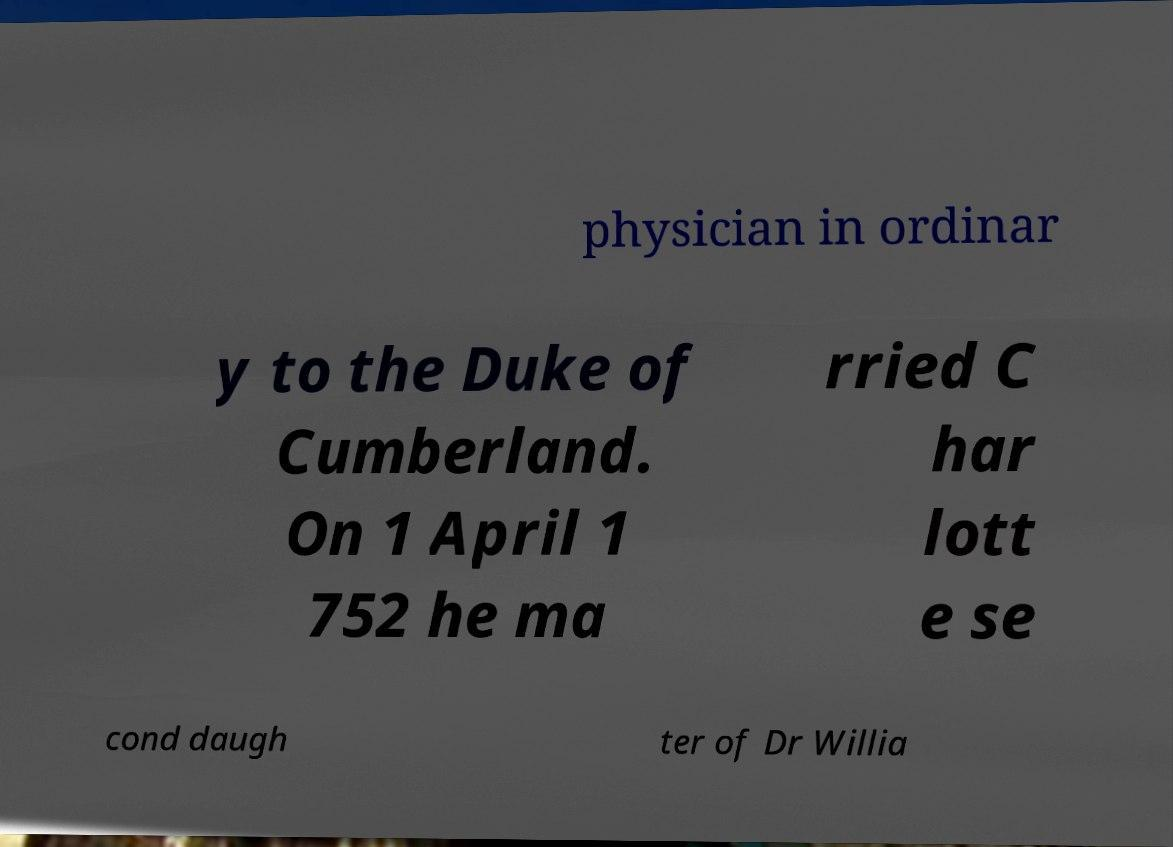Can you accurately transcribe the text from the provided image for me? physician in ordinar y to the Duke of Cumberland. On 1 April 1 752 he ma rried C har lott e se cond daugh ter of Dr Willia 